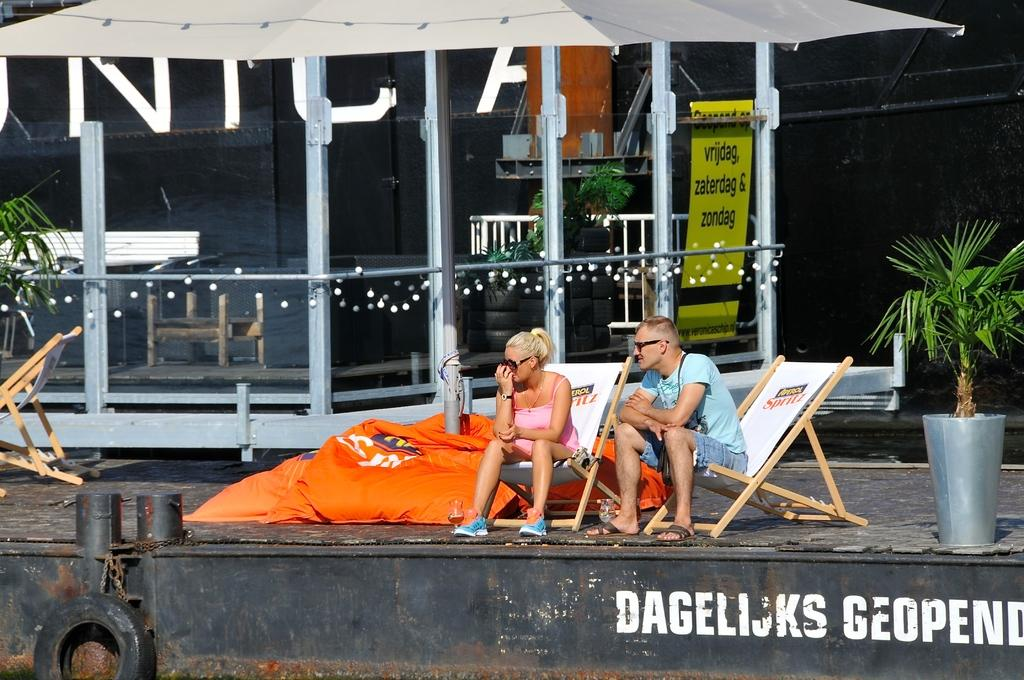How many people are sitting in the image? There are two people sitting on chairs in the image. What can be seen besides the people in the image? There is a plant, a tire, a banner, lights, additional tires, and another plant visible in the image. Can you describe the background of the image? The background of the image includes a banner, lights, and additional tires. Are there any plants in the background? Yes, there is another plant in the background. What type of poison is hidden in the tire in the image? There is no poison present in the image; it only features a tire and other objects. What kind of jewel can be seen on the shirt of one of the people in the image? There is no shirt or jewel mentioned in the image; it only features two people sitting on chairs. 